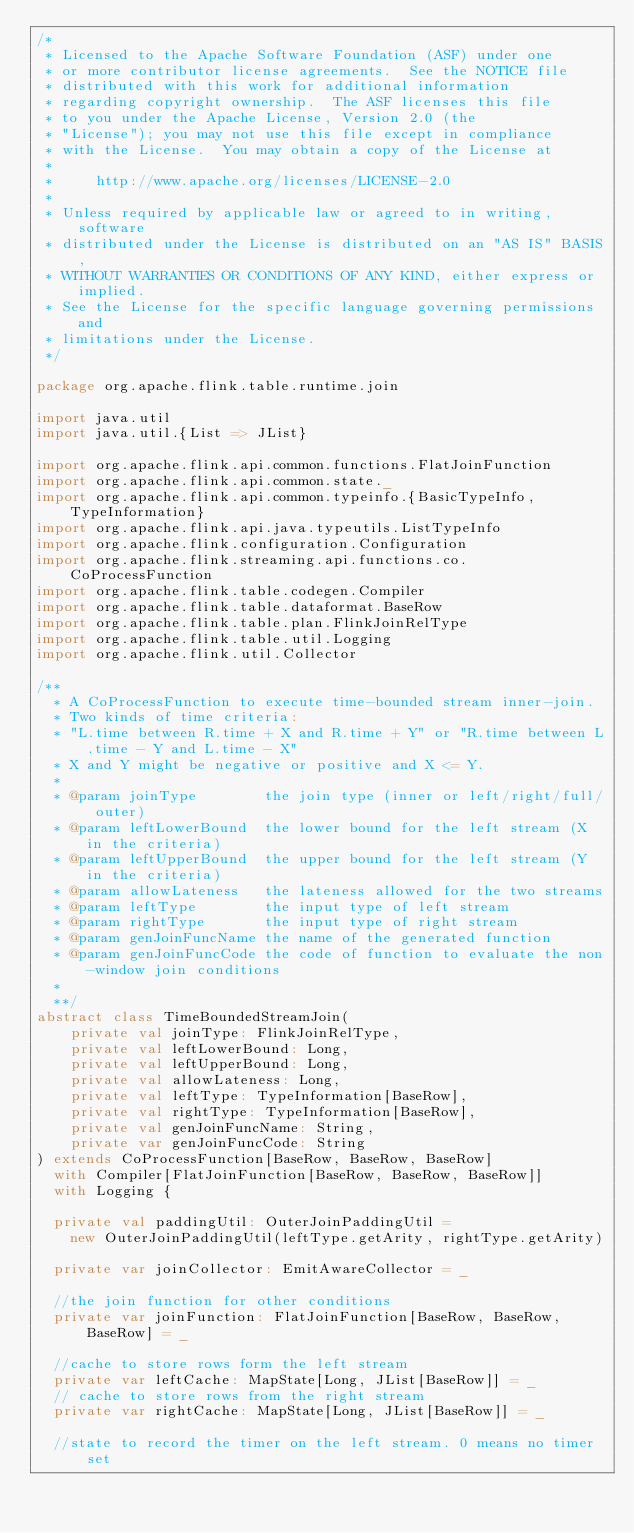<code> <loc_0><loc_0><loc_500><loc_500><_Scala_>/*
 * Licensed to the Apache Software Foundation (ASF) under one
 * or more contributor license agreements.  See the NOTICE file
 * distributed with this work for additional information
 * regarding copyright ownership.  The ASF licenses this file
 * to you under the Apache License, Version 2.0 (the
 * "License"); you may not use this file except in compliance
 * with the License.  You may obtain a copy of the License at
 *
 *     http://www.apache.org/licenses/LICENSE-2.0
 *
 * Unless required by applicable law or agreed to in writing, software
 * distributed under the License is distributed on an "AS IS" BASIS,
 * WITHOUT WARRANTIES OR CONDITIONS OF ANY KIND, either express or implied.
 * See the License for the specific language governing permissions and
 * limitations under the License.
 */

package org.apache.flink.table.runtime.join

import java.util
import java.util.{List => JList}

import org.apache.flink.api.common.functions.FlatJoinFunction
import org.apache.flink.api.common.state._
import org.apache.flink.api.common.typeinfo.{BasicTypeInfo, TypeInformation}
import org.apache.flink.api.java.typeutils.ListTypeInfo
import org.apache.flink.configuration.Configuration
import org.apache.flink.streaming.api.functions.co.CoProcessFunction
import org.apache.flink.table.codegen.Compiler
import org.apache.flink.table.dataformat.BaseRow
import org.apache.flink.table.plan.FlinkJoinRelType
import org.apache.flink.table.util.Logging
import org.apache.flink.util.Collector

/**
  * A CoProcessFunction to execute time-bounded stream inner-join.
  * Two kinds of time criteria:
  * "L.time between R.time + X and R.time + Y" or "R.time between L.time - Y and L.time - X"
  * X and Y might be negative or positive and X <= Y.
  *
  * @param joinType        the join type (inner or left/right/full/ outer)
  * @param leftLowerBound  the lower bound for the left stream (X in the criteria)
  * @param leftUpperBound  the upper bound for the left stream (Y in the criteria)
  * @param allowLateness   the lateness allowed for the two streams
  * @param leftType        the input type of left stream
  * @param rightType       the input type of right stream
  * @param genJoinFuncName the name of the generated function
  * @param genJoinFuncCode the code of function to evaluate the non-window join conditions
  *
  **/
abstract class TimeBoundedStreamJoin(
    private val joinType: FlinkJoinRelType,
    private val leftLowerBound: Long,
    private val leftUpperBound: Long,
    private val allowLateness: Long,
    private val leftType: TypeInformation[BaseRow],
    private val rightType: TypeInformation[BaseRow],
    private val genJoinFuncName: String,
    private var genJoinFuncCode: String
) extends CoProcessFunction[BaseRow, BaseRow, BaseRow]
  with Compiler[FlatJoinFunction[BaseRow, BaseRow, BaseRow]]
  with Logging {

  private val paddingUtil: OuterJoinPaddingUtil =
    new OuterJoinPaddingUtil(leftType.getArity, rightType.getArity)

  private var joinCollector: EmitAwareCollector = _

  //the join function for other conditions
  private var joinFunction: FlatJoinFunction[BaseRow, BaseRow, BaseRow] = _

  //cache to store rows form the left stream
  private var leftCache: MapState[Long, JList[BaseRow]] = _
  // cache to store rows from the right stream
  private var rightCache: MapState[Long, JList[BaseRow]] = _

  //state to record the timer on the left stream. 0 means no timer set</code> 